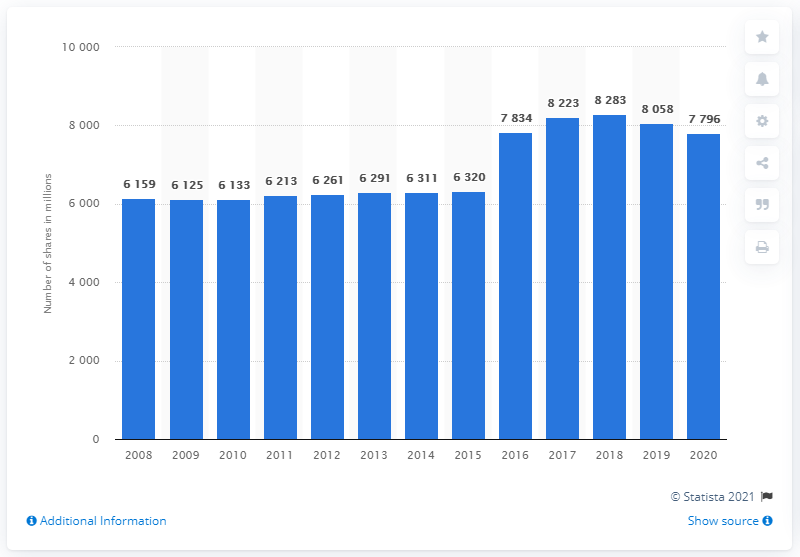Outline some significant characteristics in this image. In 2008, there were 6,261 available shares. In 2020, Royal Dutch Shell had a total of 7,796 shares. 